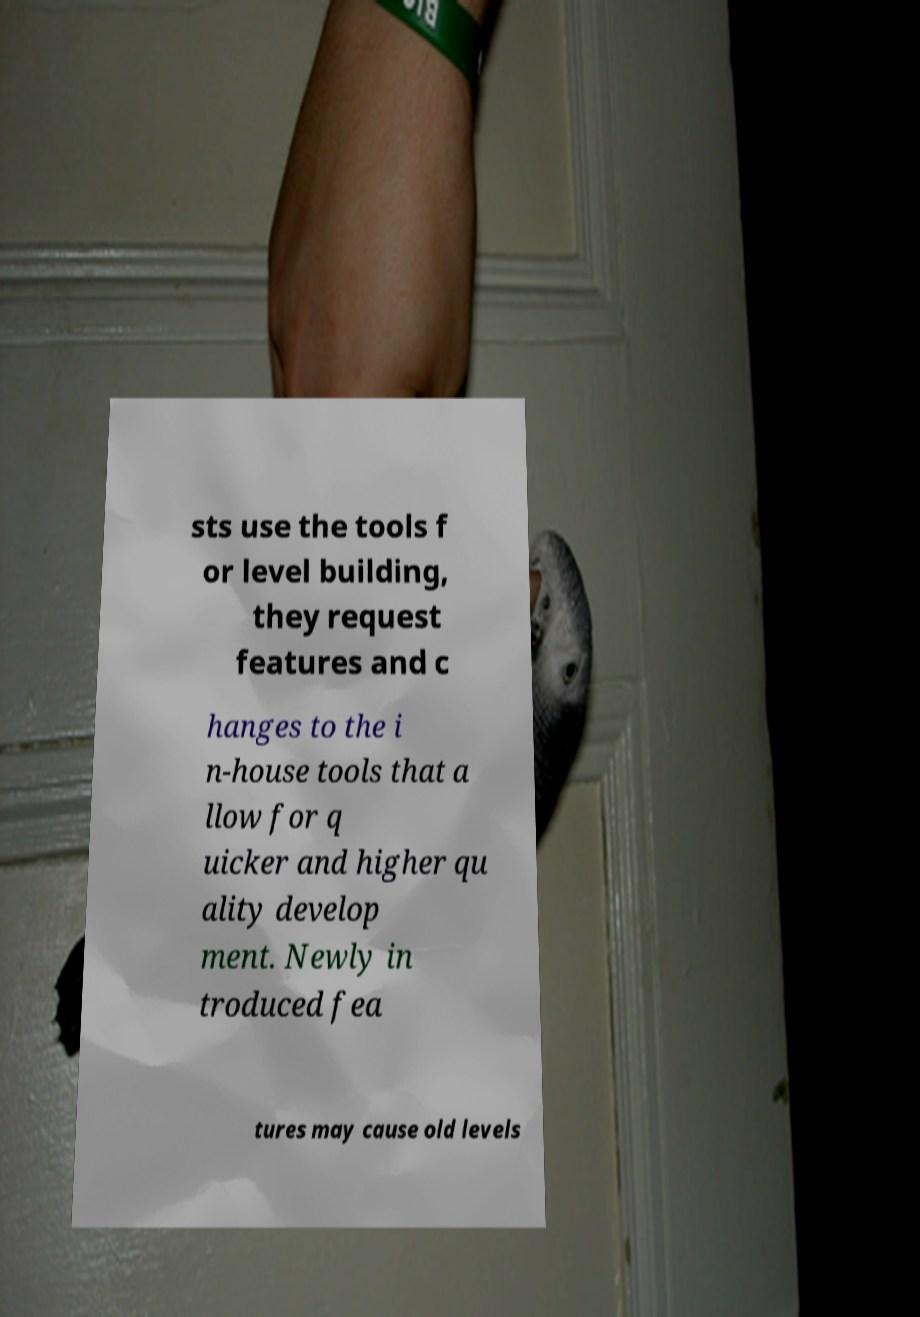Could you assist in decoding the text presented in this image and type it out clearly? sts use the tools f or level building, they request features and c hanges to the i n-house tools that a llow for q uicker and higher qu ality develop ment. Newly in troduced fea tures may cause old levels 